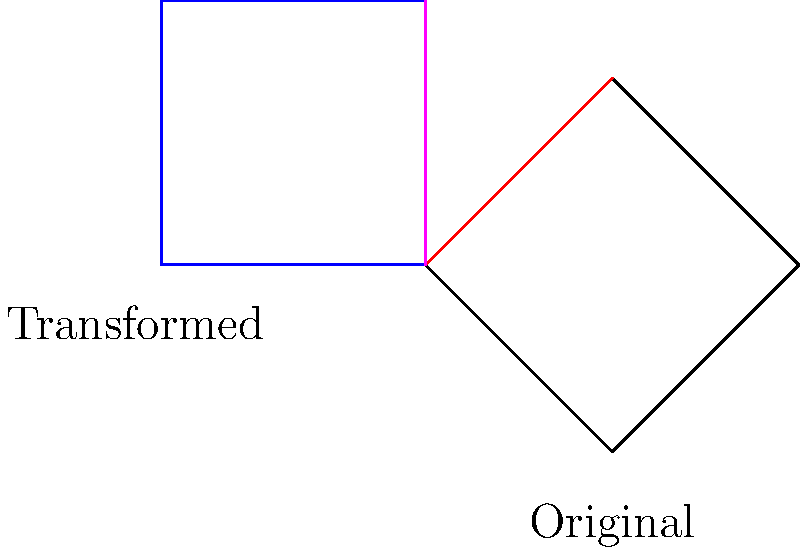Consider the Penrose diagram of a Schwarzschild black hole shown in black. A transformation consisting of a 45-degree clockwise rotation followed by a reflection across the line y=x is applied to the diagram, resulting in the blue figure. How does this transformation affect the causal structure of the black hole spacetime as represented in the Penrose diagram? Specifically, what happens to the event horizon and singularity? To understand the effect of the transformation on the causal structure of the black hole spacetime, we need to analyze the changes in the key features of the Penrose diagram:

1. Original diagram:
   - The event horizon is represented by the red line from (0,0) to (1,1).
   - The singularity is represented by the dashed line from (1,1) to (2,0).
   - The diagram is symmetric about the vertical axis.

2. Transformation applied:
   - 45-degree clockwise rotation
   - Reflection across the line y=x

3. Effects of the transformation:
   a) Event horizon:
      - The rotation moves the horizon counterclockwise.
      - The reflection flips it across the y=x line.
      - Result: The horizon now extends from the bottom-left to the top-right of the diagram.

   b) Singularity:
      - The rotation moves the singularity counterclockwise.
      - The reflection flips it across the y=x line.
      - Result: The singularity now extends from the top-right to the bottom-right of the diagram.

4. Causal structure implications:
   - The overall shape of the diagram is preserved, maintaining the causal structure.
   - The orientation of the diagram has changed, but the relative positions of the horizon and singularity remain the same.
   - The future and past null infinities (I+ and I-) have switched positions.
   - The regions inside and outside the horizon maintain their causal relationships.

5. Physical interpretation:
   - The transformation does not change the fundamental causal structure of the spacetime.
   - It represents a change in perspective or coordinate choice rather than a physical change in the black hole.
   - The transformed diagram still correctly represents the causal relationships and event horizon structure of a Schwarzschild black hole.

In conclusion, while the transformation alters the orientation of the Penrose diagram, it does not fundamentally change the causal structure of the black hole spacetime. The event horizon and singularity maintain their relative positions and causal relationships, preserving the essential features of the Schwarzschild black hole.
Answer: The transformation preserves the causal structure, reorienting the diagram without altering the fundamental relationships between the event horizon, singularity, and spacetime regions. 